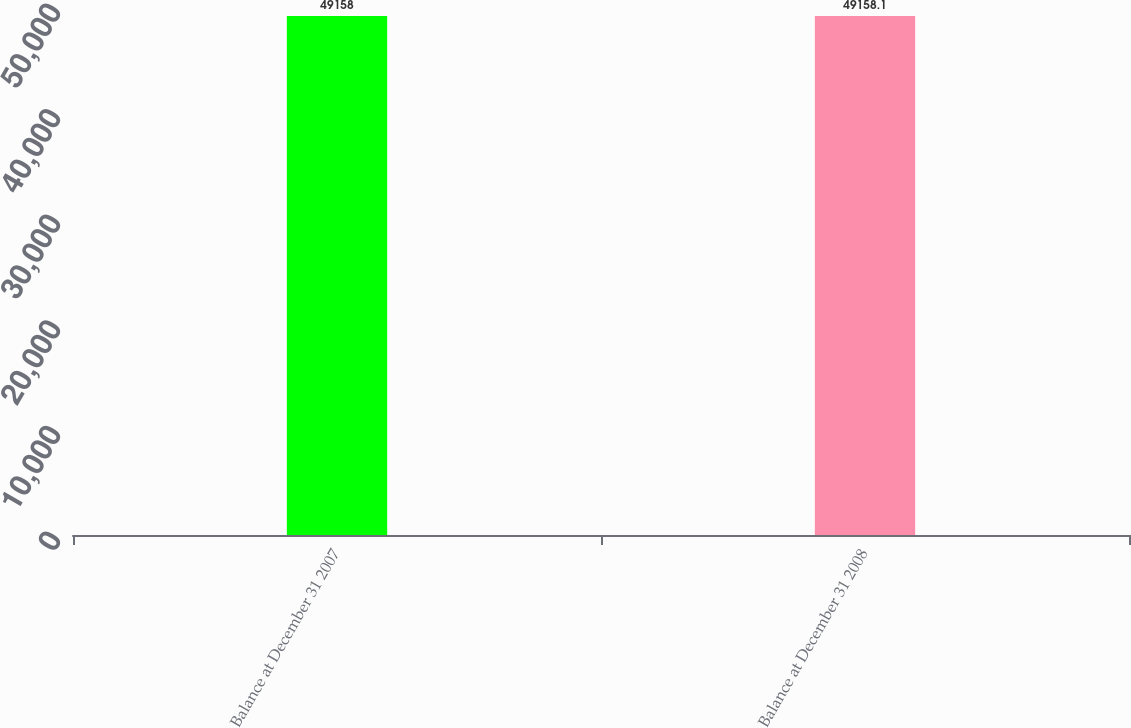Convert chart to OTSL. <chart><loc_0><loc_0><loc_500><loc_500><bar_chart><fcel>Balance at December 31 2007<fcel>Balance at December 31 2008<nl><fcel>49158<fcel>49158.1<nl></chart> 